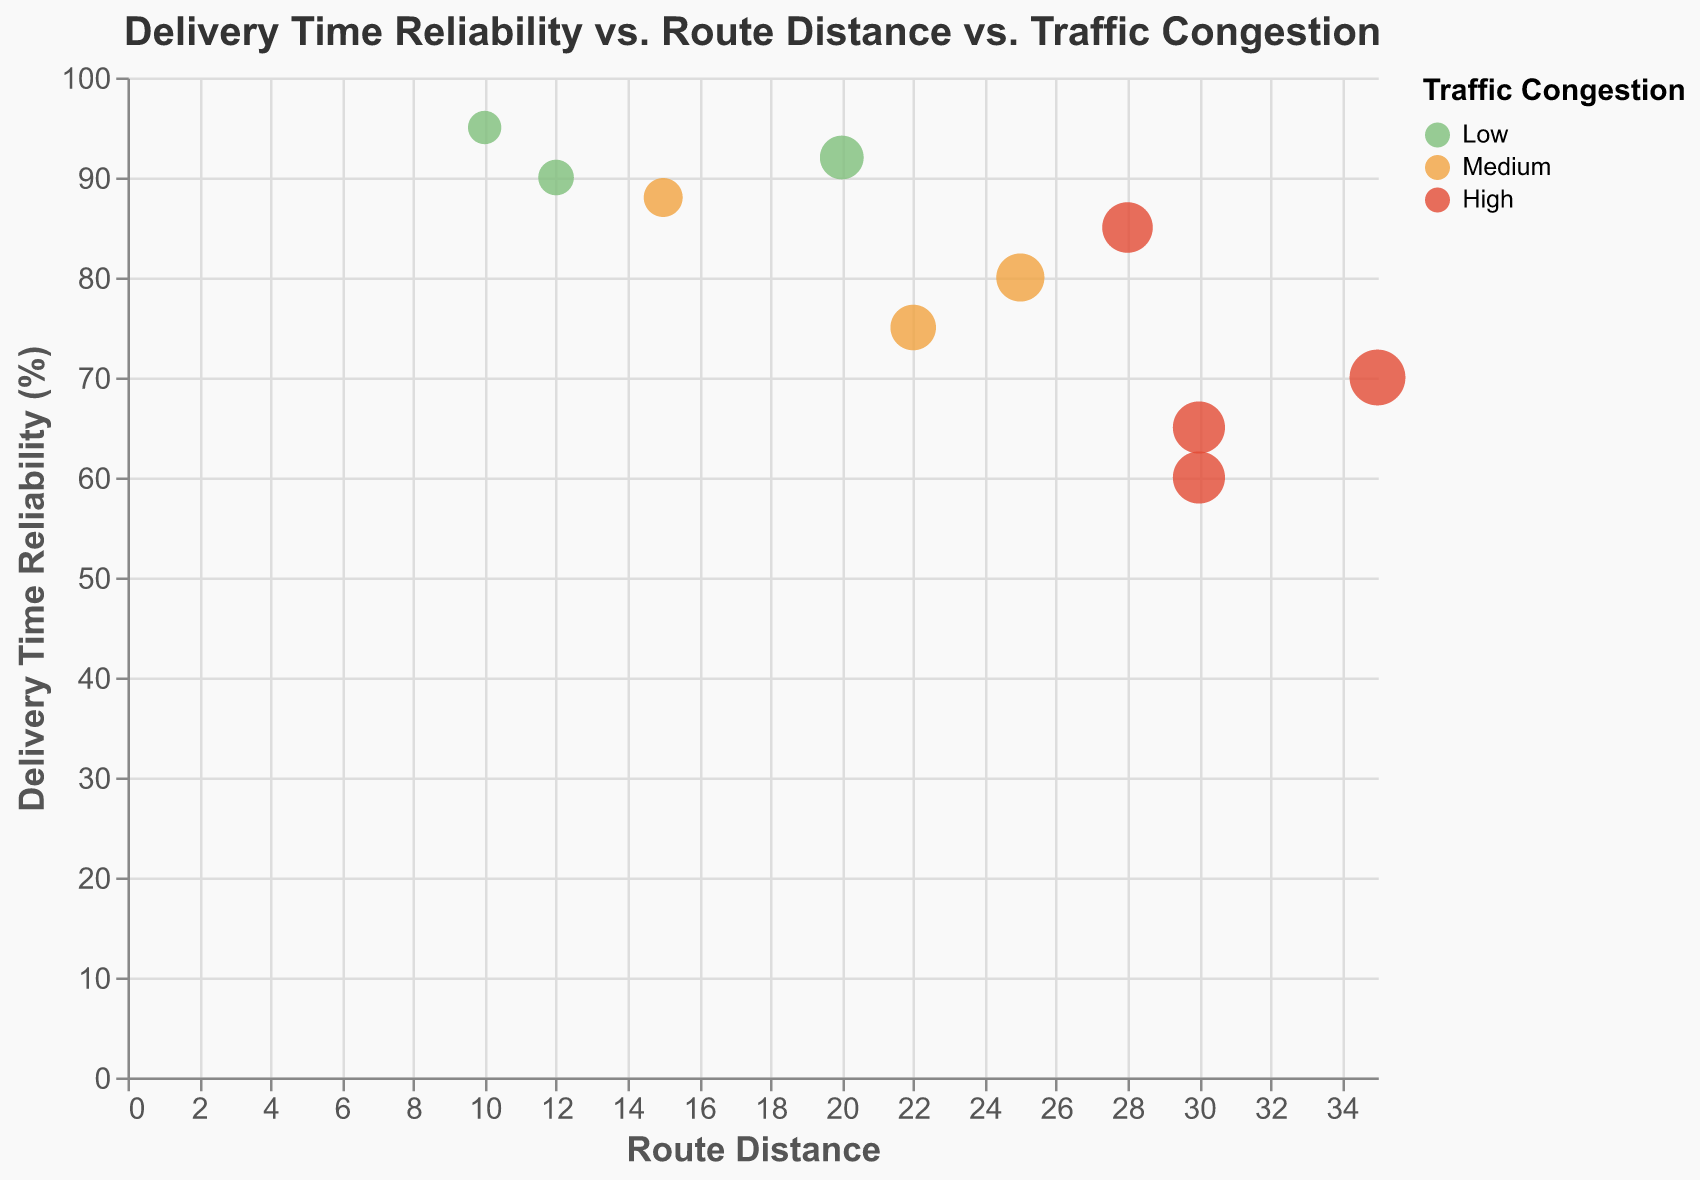How many routes have low traffic congestion levels? Look at the legend and count the bubbles colored green, which represent low traffic congestion levels. There are three such bubbles.
Answer: 3 Which route has the highest delivery time reliability? Identify the bubble with the highest y-axis value, which represents delivery time reliability. The bubble corresponding to Route 1 has the highest delivery time reliability of 95%.
Answer: Route 1 What is the traffic congestion level and carrier for the route with the longest route distance? Find the bubble with the largest size which represents the longest route distance on the x-axis. Route 6 has the longest route distance of 35. The traffic congestion level is high, and the carrier is Carrier D.
Answer: High, Carrier D Compare delivery time reliability between Route 2 and Route 5. Which one is higher? Check the y-axis values for Route 2 and Route 5. Route 2 has a delivery time reliability of 80, whereas Route 5 has a reliability of 92, indicating Route 5 has a higher delivery time reliability.
Answer: Route 5 What is the average delivery time reliability for routes with medium traffic congestion? Identify routes with medium traffic congestion (orange bubbles): Route 2, Route 4, and Route 9. The delivery time reliability values are 80, 88, and 75 respectively. Calculate the average: (80+88+75)/3 = 243/3 = 81
Answer: 81 Among routes carried by Carrier A, which route has the lowest delivery time reliability? Find the bubbles corresponding to Carrier A and compare their y-axis values. Routes by Carrier A are Route 1, Route 4, and Route 9. Their delivery time reliability values are 95, 88, and 75 respectively. Route 9 has the lowest delivery time reliability.
Answer: Route 9 Which route with high traffic congestion has the highest delivery time reliability? Identify the bubbles colored red, indicating high traffic congestion: Route 3, Route 6, Route 7, Route 10. Compare their y-axis values and find the highest. Route 7 has the highest delivery time reliability of 85.
Answer: Route 7 Compare the route distances between the route with the highest and lowest delivery time reliability. What are their respective distances? Route 1 has the highest delivery time reliability and a distance of 10. Route 3 has the lowest delivery time reliability and a distance of 30. Compare 10 and 30.
Answer: 10 and 30 What is the difference in delivery time reliability between the shortest and longest routes? Find the shortest route (smallest size bubble) and the longest route (largest size bubble). Compare their y-axis values: Route 1 (shortest, 95) and Route 6 (longest, 70). The difference is 95 - 70 = 25.
Answer: 25 